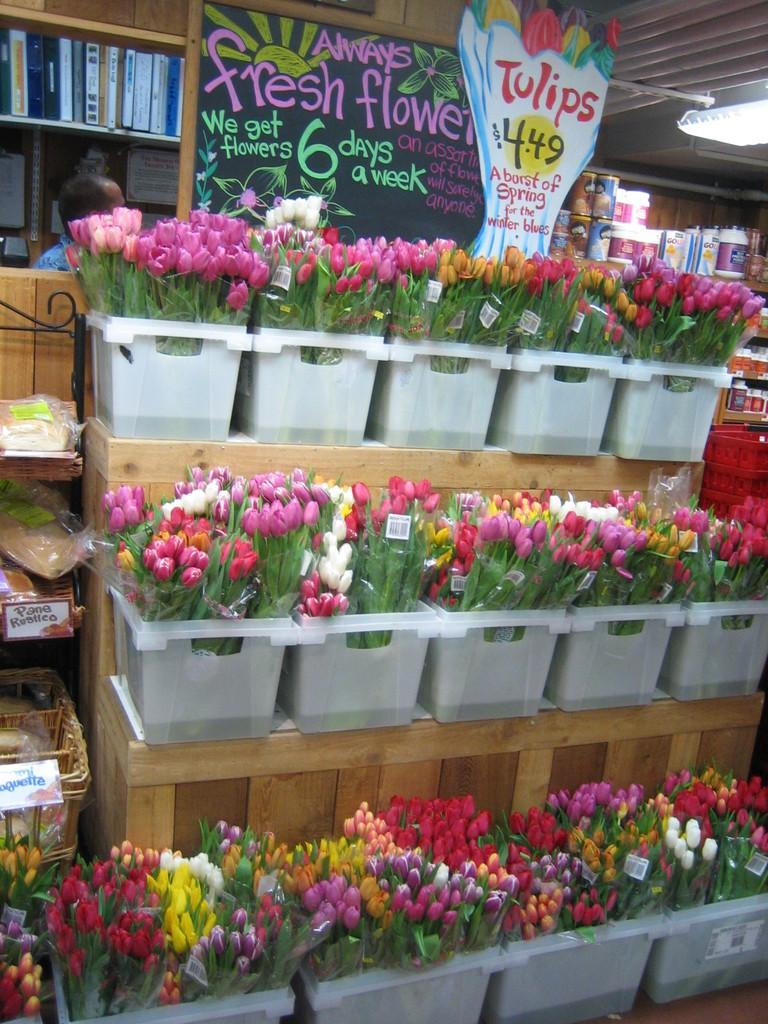What type of flowers are in the image? The flowers in the image have covers and are in plastic containers. What are the containers placed on? The containers are on wooden boards. What else can be seen in the image besides the flowers and containers? There are items visible in the image, including a light and a person. Where are the books located in the image? The books are in a shelf in the image. How many goldfish are swimming in the wooden boards in the image? There are no goldfish present in the image; it features flowers in containers on wooden boards. What type of company is the person in the image representing? The image does not provide any information about the person's company or affiliation. 